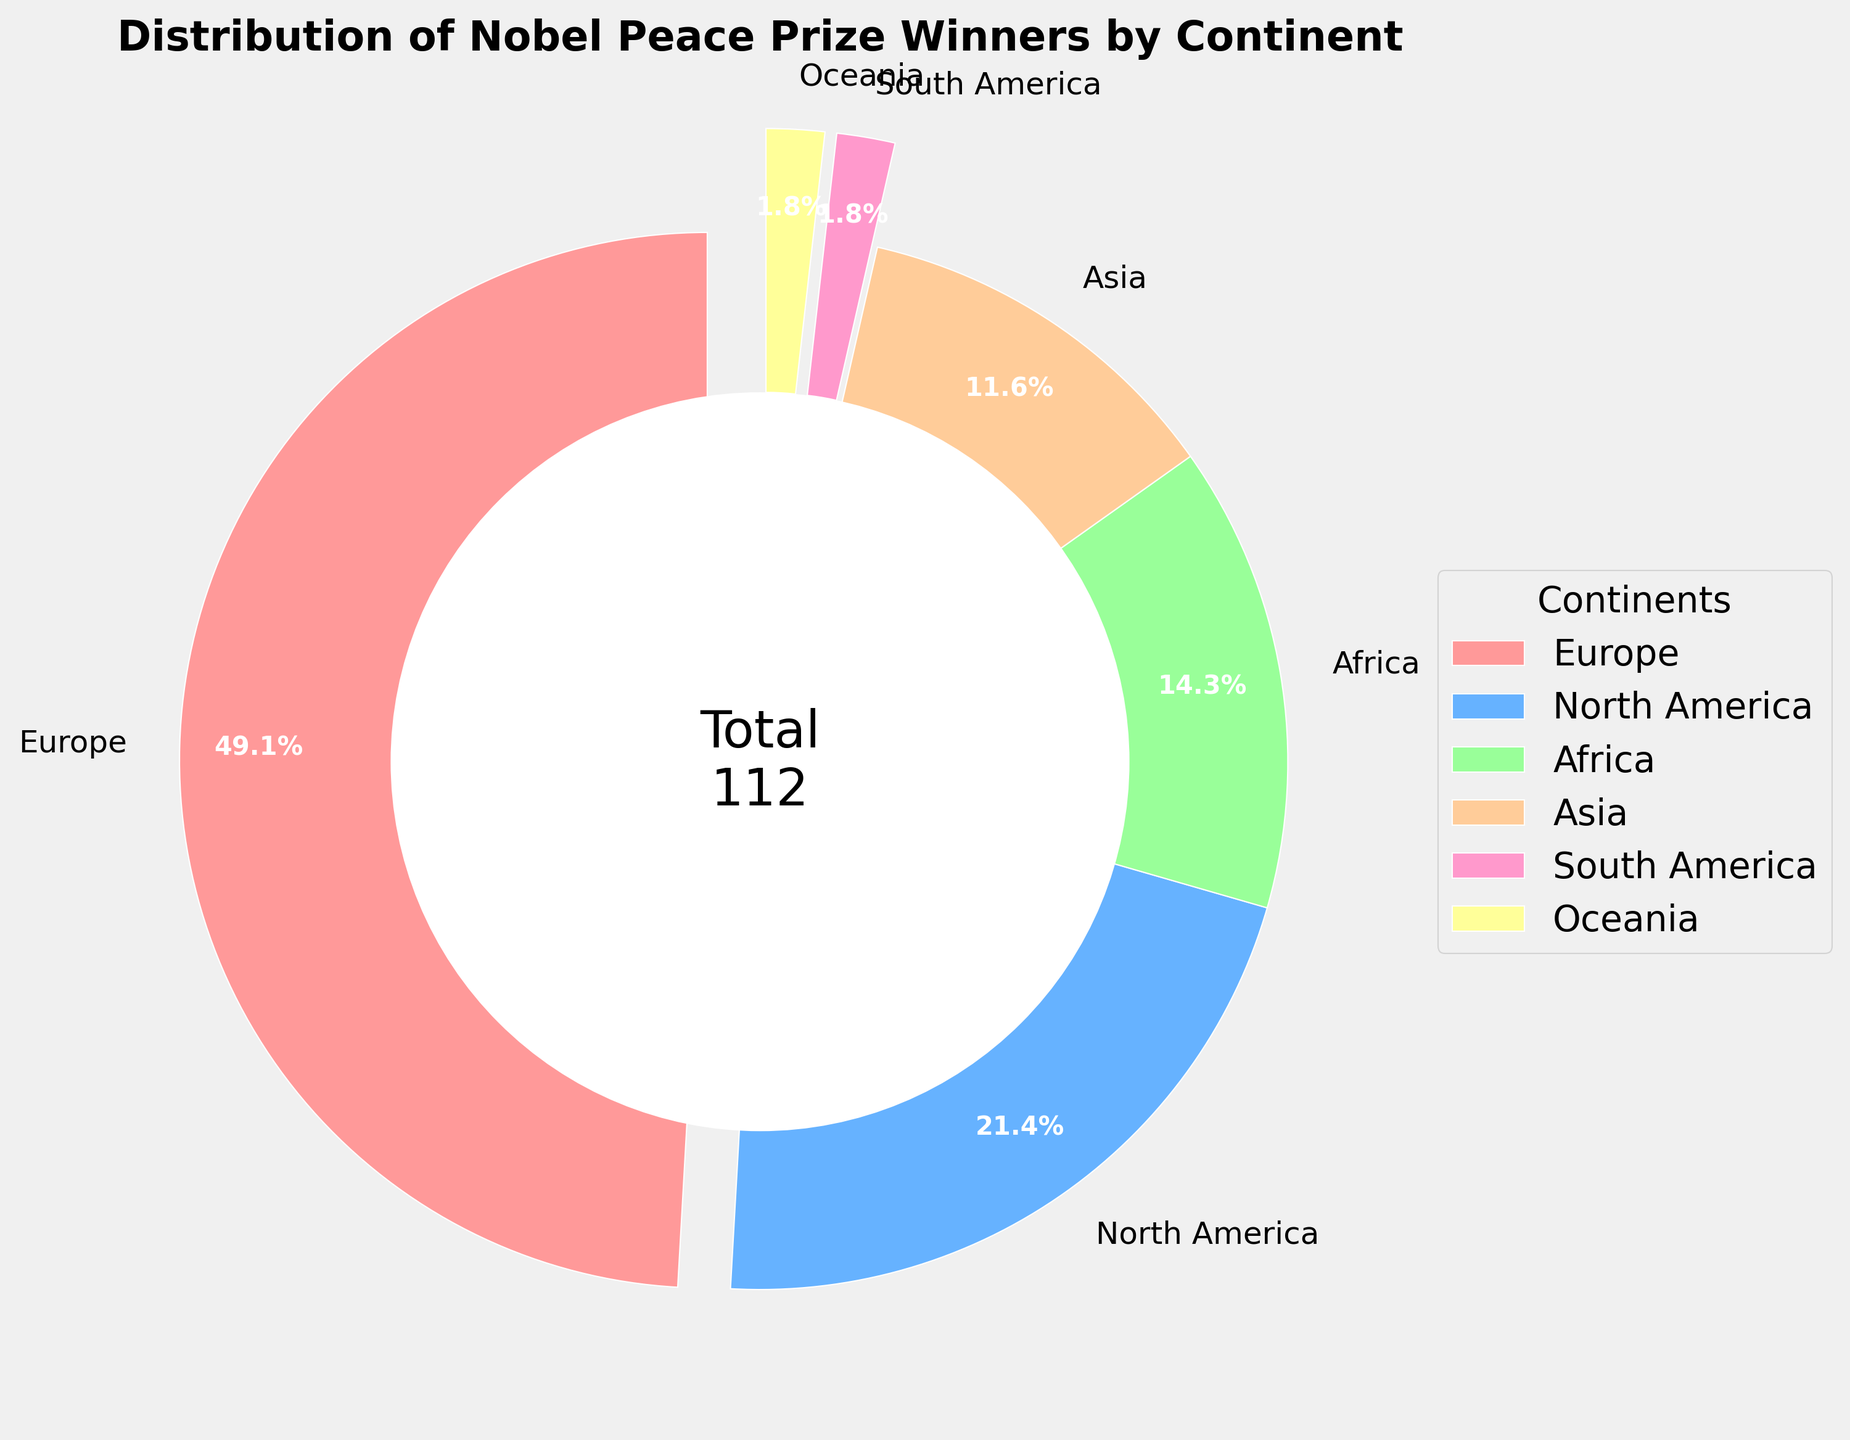What percentage of Nobel Peace Prize winners are from Europe? Look at the pie slice labeled "Europe" and see the percentage listed beside it. The percentage is 55%
Answer: 55% Which continent has the least Nobel Peace Prize winners and how many do they have? Identify the smallest pie slices and their labels. Both South America and Oceania have the smallest slices, each with 2 winners
Answer: South America and Oceania, 2 How many more Nobel Peace Prize winners does North America have compared to Asia? Find the number of winners for North America and Asia and subtract the two values (24 - 13 = 11)
Answer: 11 What is the combined percentage of Nobel Peace Prize winners from Africa and Asia? Combine the percentages of Africa and Asia. Africa has 16%, and Asia has 13%, so their combined percentage is 16% + 13% = 29%
Answer: 29% Which continent has more Nobel Peace Prize winners, Africa or South America? Compare the number of winners for Africa (16) and South America (2). Africa has more
Answer: Africa What is the percentage difference between Europe and North America's Nobel Peace Prize winners? Subtract the percentage of North America from Europe. Europe has 55% and North America has 24%, so the difference is 55% - 24% = 31%
Answer: 31% What is the visual feature of the pie chart that symbolizes the total number of Nobel Peace Prize winners? Look at the center of the pie chart, where there is a textual depiction representing the total number of winners (112)
Answer: 112 in the center Which color represents Africa in the pie chart? Identify the color used for the slice labeled "Africa". Africa is represented by a green slice
Answer: Green If we combine the winners from South America and Oceania, what fraction of the total Nobel Peace Prize winners do they represent? Add the winners from South America and Oceania (2 + 2 = 4) and then divide by the total number of winners (4 / 112). The fraction simplifies to 1/28
Answer: 1/28 What's the combined total number of Nobel Peace Prize winners from Europe, North America, and Africa? Add the numbers of winners from Europe, North America, and Africa (55 + 24 + 16 = 95)
Answer: 95 